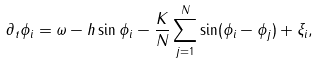<formula> <loc_0><loc_0><loc_500><loc_500>\partial _ { t } \phi _ { i } & = \omega - h \sin \phi _ { i } - \frac { K } { N } \sum _ { j = 1 } ^ { N } \sin ( \phi _ { i } - \phi _ { j } ) + \xi _ { i } ,</formula> 